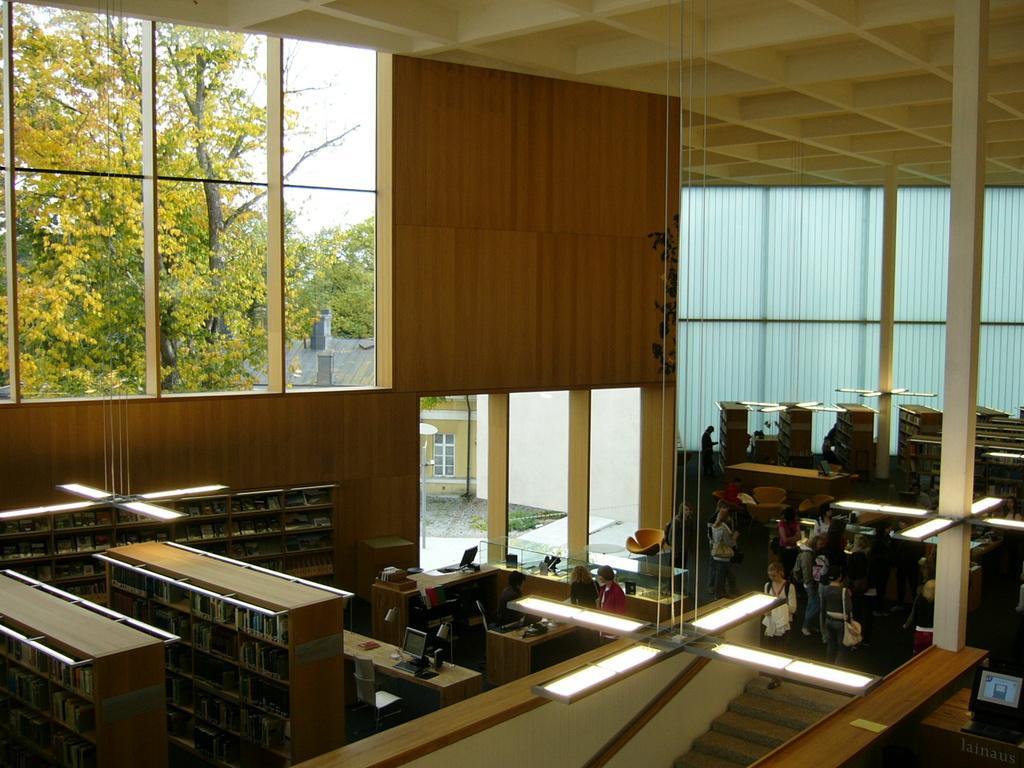Describe this image in one or two sentences. This image looks like it is clicked inside the room. To the left, there are racks in that some books are kept. In the middle there are two persons. To the right, there are many people standing. At the top there a roof. 